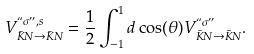<formula> <loc_0><loc_0><loc_500><loc_500>V ^ { ` ` \sigma { ^ { \prime \prime } } , s } _ { \bar { K } N \rightarrow \bar { K } N } = \frac { 1 } { 2 } \int _ { - 1 } ^ { 1 } d \cos ( \theta ) V ^ { ` ` \sigma { ^ { \prime \prime } } } _ { \bar { K } N \rightarrow \bar { K } N } .</formula> 